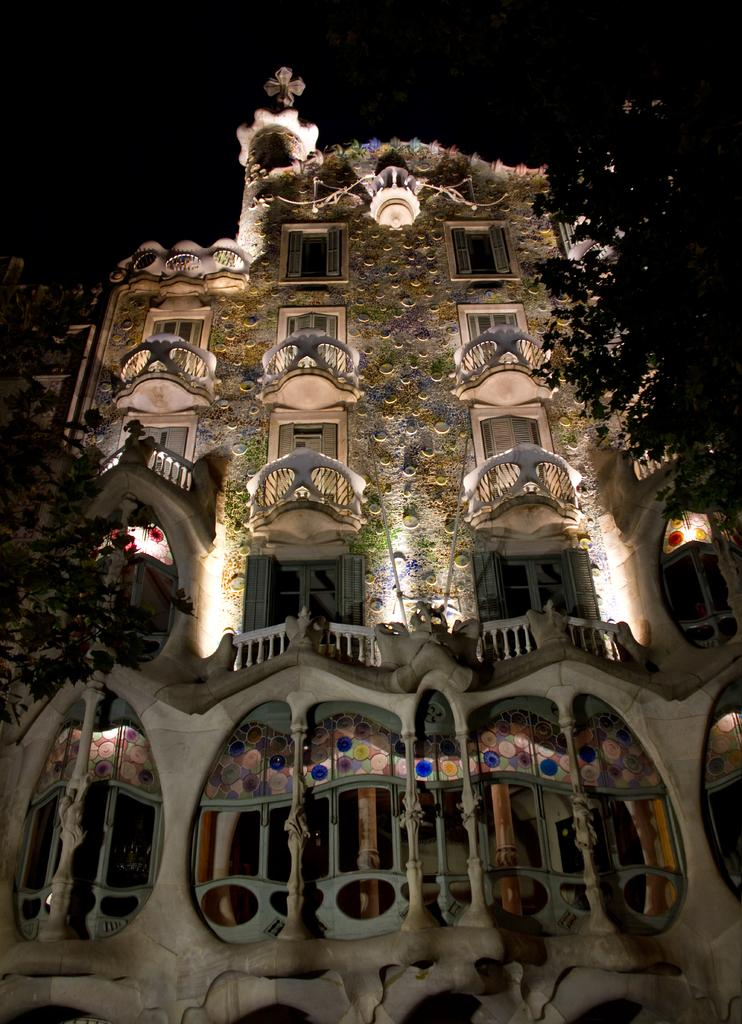What type of structure is present in the image? There is a building in the image. What feature can be seen on the building? The building has windows. What natural element is visible in the image? There is a tree visible in the image. Can you see any spies playing chess with mittens in the image? There are no spies, chess games, or mittens present in the image. 